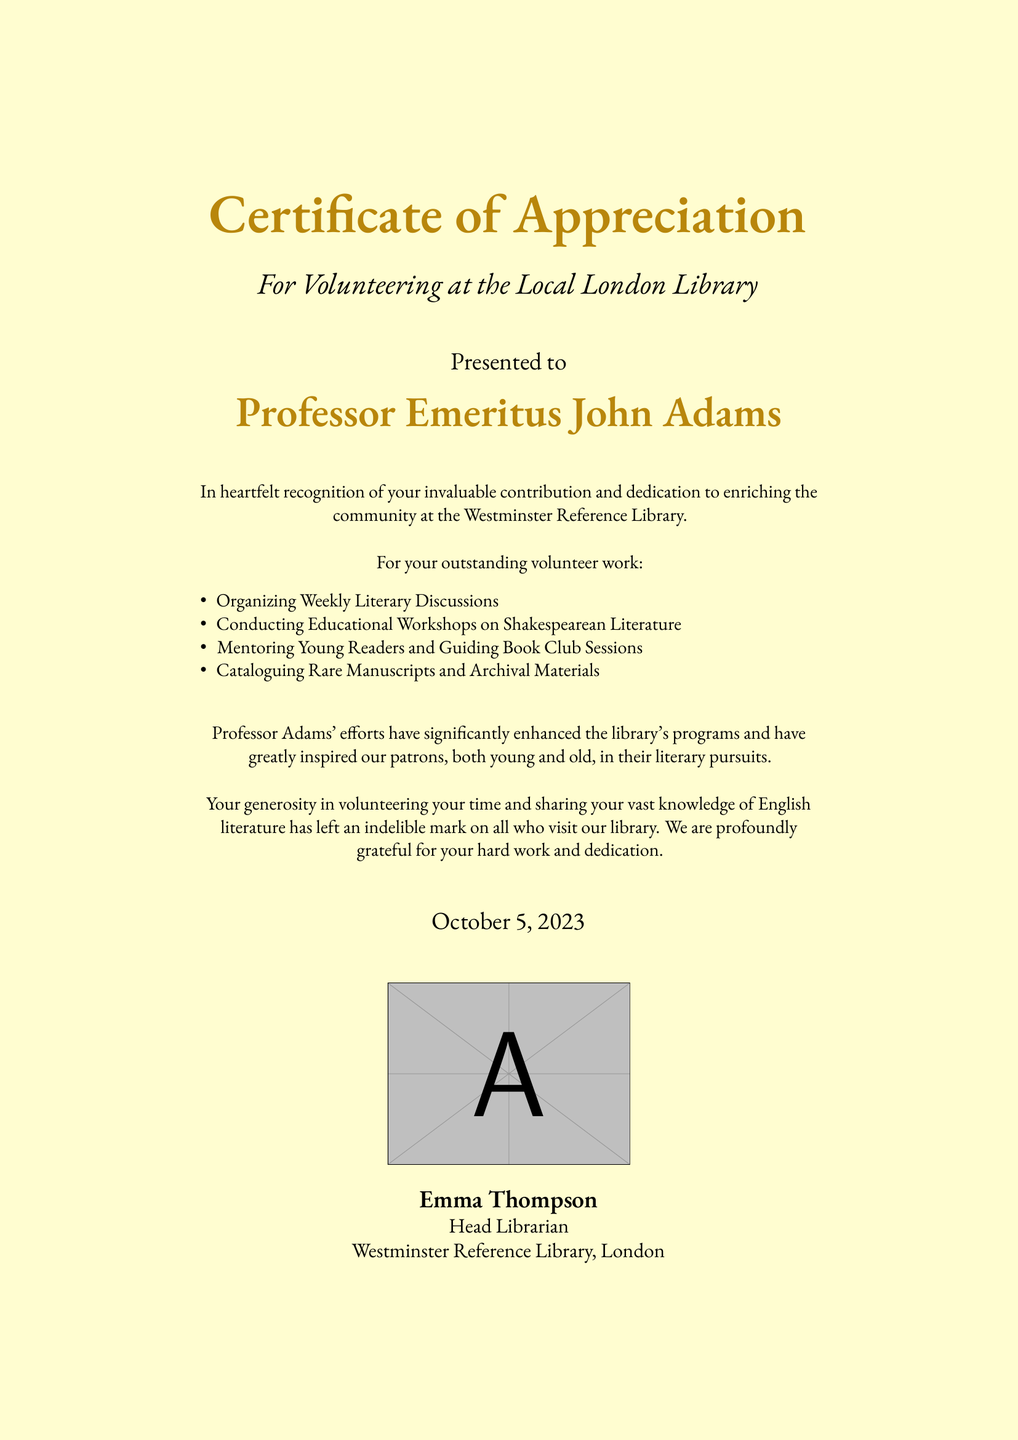What is the title of the document? The title is prominently featured at the top of the certificate.
Answer: Certificate of Appreciation Who is the certificate presented to? The recipient's name is clearly stated below the title in the document.
Answer: Professor Emeritus John Adams What date is written on the certificate? The date is mentioned towards the bottom of the document.
Answer: October 5, 2023 What organization is associated with this certificate? The associated organization is specified at the end of the document.
Answer: Westminster Reference Library What type of contributions did Professor Adams make? The contributions are listed in bullet points and describe his volunteer work.
Answer: Organizing Weekly Literary Discussions How does the document describe Professor Adams' impact? The impact is explicitly stated in a specific sentence within the document.
Answer: Indelible mark on all who visit our library Who signed the certificate? The signature or name of the person who issued the certificate is found at the bottom.
Answer: Emma Thompson What color is the background of the document? The color is mentioned in the document's settings.
Answer: Cream How is the certificate visually emphasized? The visual elements, including details and design choices, contribute to its presentation.
Answer: Gold accent 